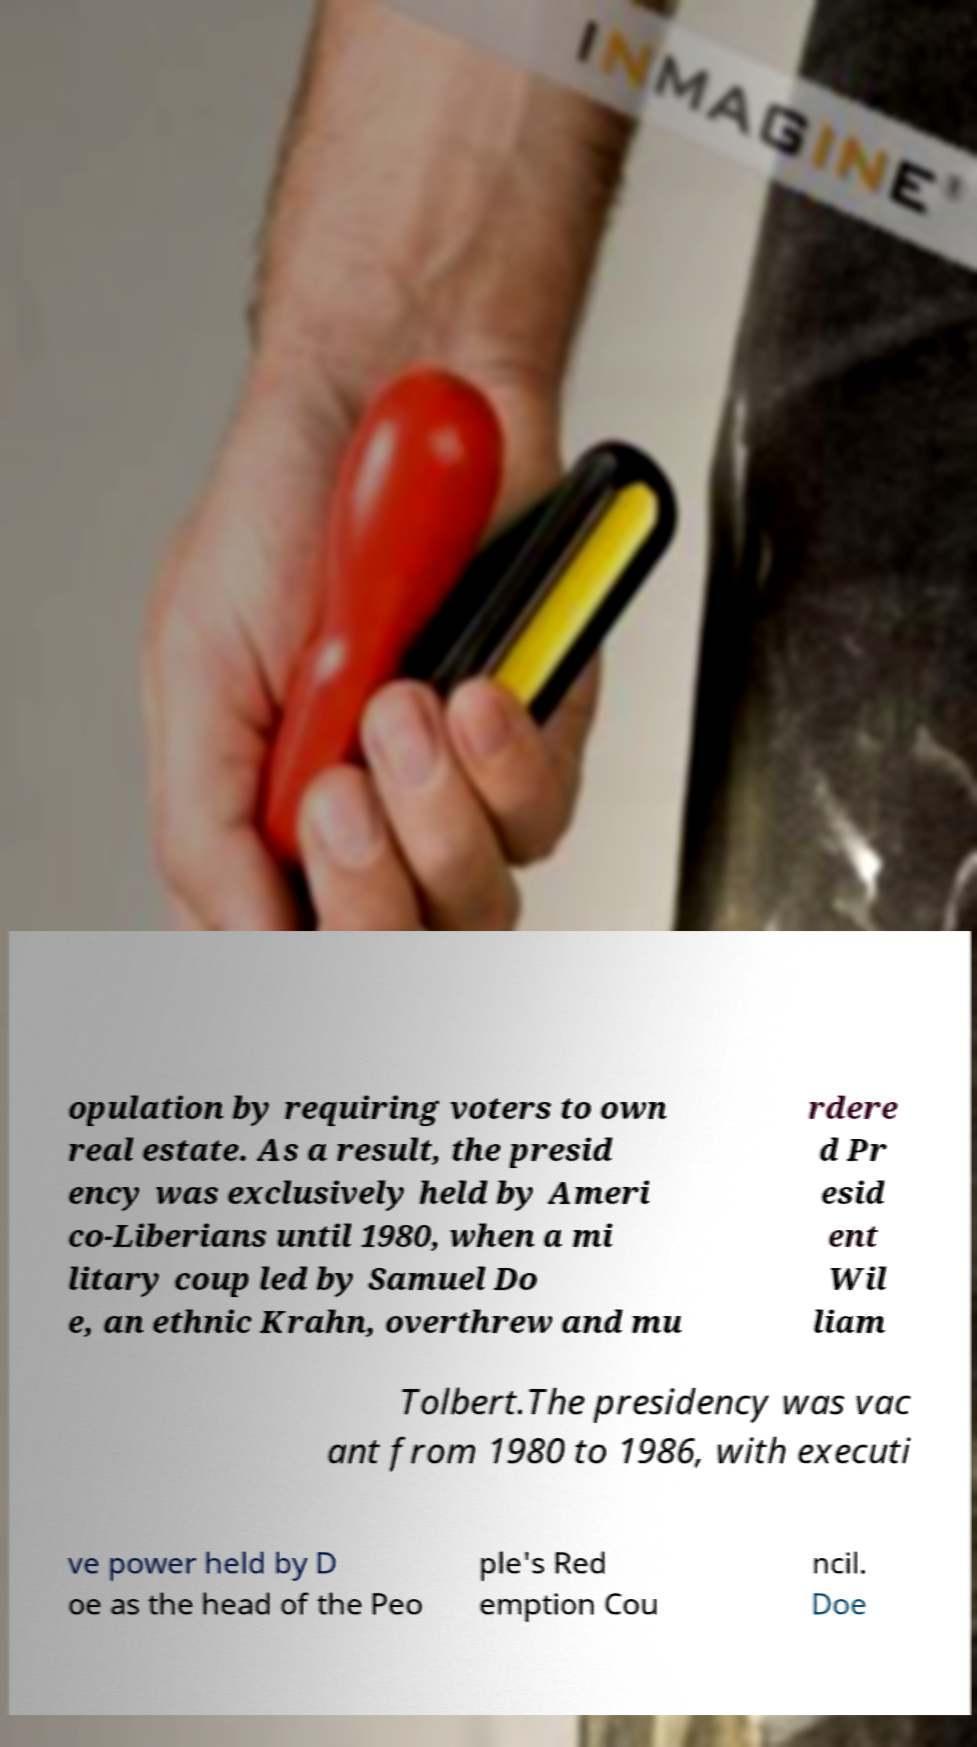Can you read and provide the text displayed in the image?This photo seems to have some interesting text. Can you extract and type it out for me? opulation by requiring voters to own real estate. As a result, the presid ency was exclusively held by Ameri co-Liberians until 1980, when a mi litary coup led by Samuel Do e, an ethnic Krahn, overthrew and mu rdere d Pr esid ent Wil liam Tolbert.The presidency was vac ant from 1980 to 1986, with executi ve power held by D oe as the head of the Peo ple's Red emption Cou ncil. Doe 